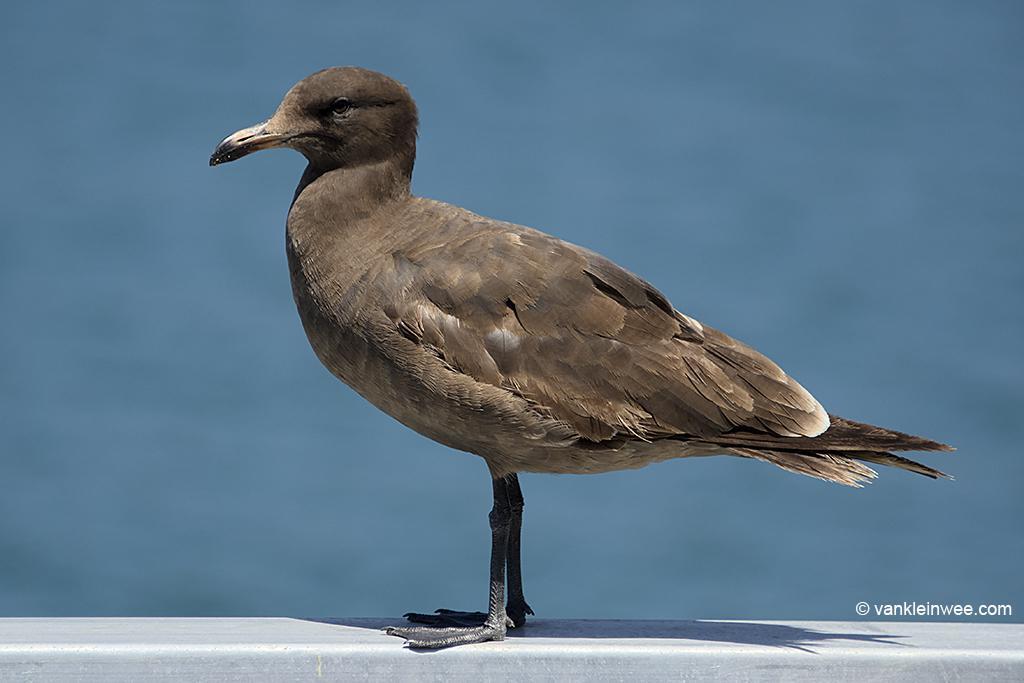Please provide a concise description of this image. In this image we can see a bird, it is in brown color, here is the eye, here is the beak, and hat background it is blue. 